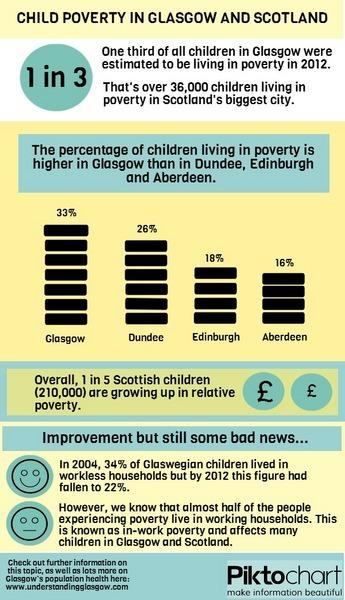Specify some key components in this picture. In Glasgow, the number of children living in workless households among Glaswegian children decreased by 12% from 2004 to 2012. After Glasgow, which city has a higher percentage of children living in poverty? The answer is Dundee. 